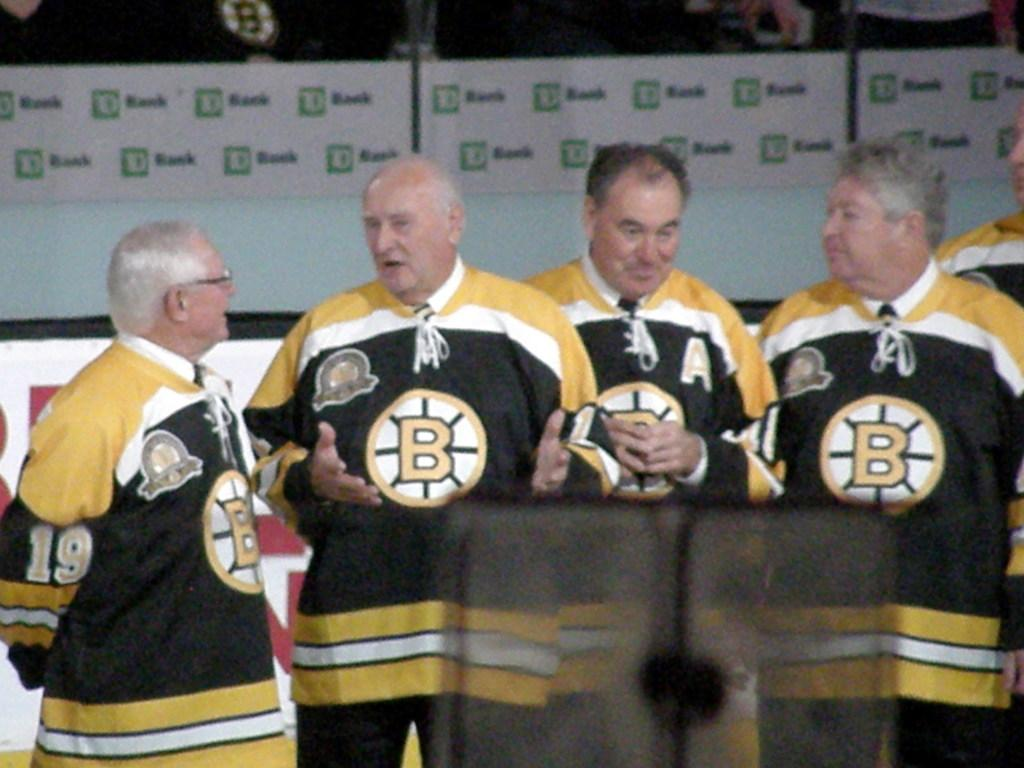Provide a one-sentence caption for the provided image. Four older men sare standing and talking. They are wearing yellow and black sweatshirts that say "B" on them. 